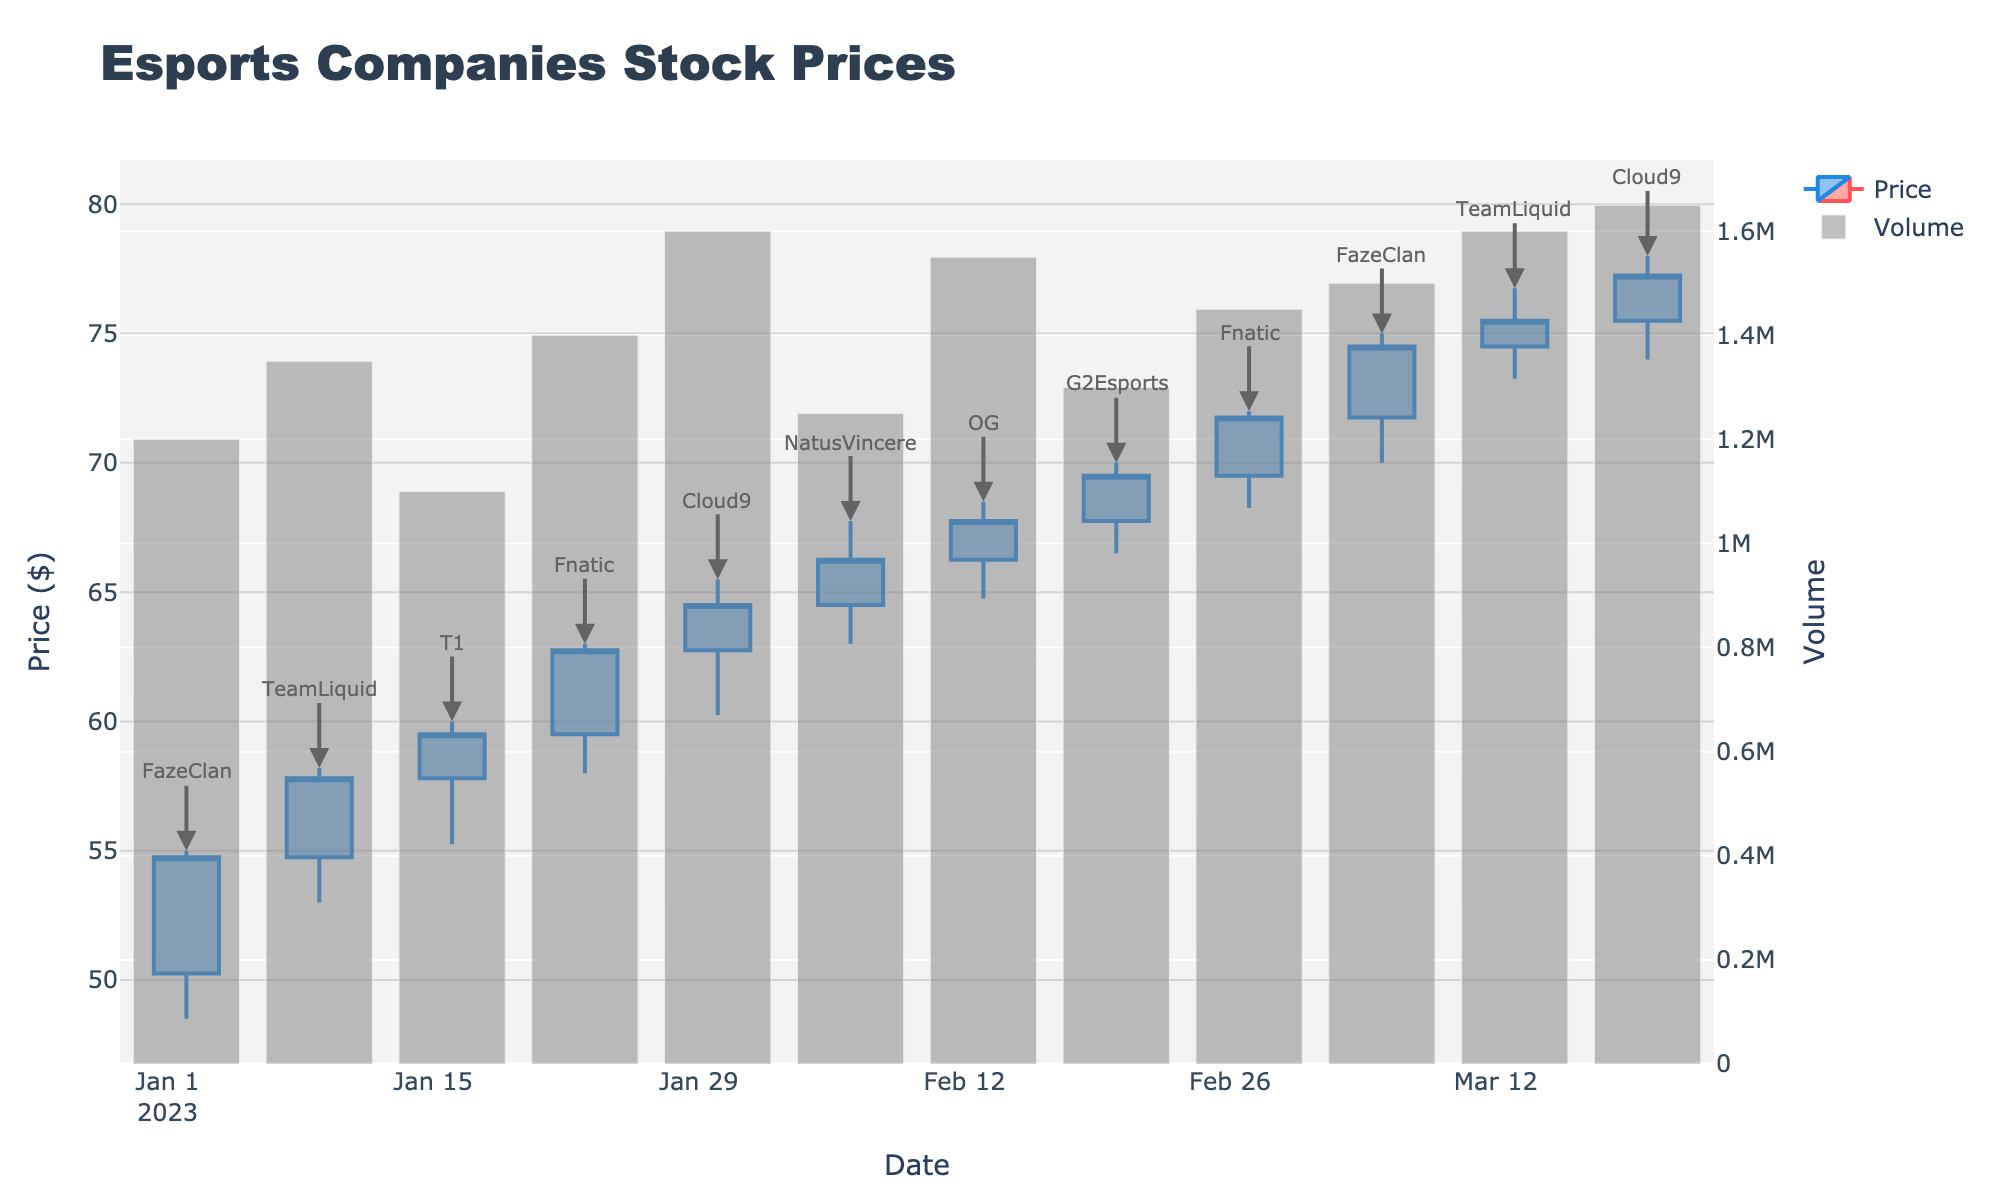What is the highest stock price recorded in the figure? Look for the candlestick with the highest "High" value on the vertical axis. The highest price recorded is 78.00 on 2023-03-20 for Cloud9.
Answer: 78.00 Which company had the highest trading volume? Refer to the volume bars at the bottom of the chart and identify the tallest bar, which corresponds to the highest trading volume. The company with the highest volume is Cloud9 on 2023-03-20, with a volume of 1,650,000.
Answer: Cloud9 How does the closing price of TeamLiquid on 2023-01-09 compare to its opening price? Check TeamLiquid’s candlestick on 2023-01-09. The candlestick is blue indicating an increase. The opening price was 54.75, and the closing price was 57.80. Calculate the difference: 57.80 - 54.75 = 3.05.
Answer: 3.05 What is the average closing price across all companies in February? List all February closing prices: 66.25, 67.75, 69.50, and 71.75. Sum these values (66.25 + 67.75 + 69.50 + 71.75 = 275.25) and divide by the number of values (275.25/4).
Answer: 68.81 Which company shows the greatest overall increase in stock price from open to close within the given dates? Compare the difference between the opening and closing prices for all companies. Start with FazeClan (2023-01-02: 4.50), TeamLiquid (2023-01-09: 3.05), T1 (2023-01-16: 1.70), Fnatic (2023-01-23: 3.25), Cloud9 (2023-02-20: 1.75), and so on. The greatest increase is seen on 2023-01-02 for FazeClan, which is 4.50.
Answer: FazeClan On which date did Fnatic experience a major increase in its stock price? Look at the candlestick annotations and identify the dates marked for Fnatic. Highlight the candlesticks and review the opening/closing prices to confirm the increase. The major increase happened on 2023-01-23, from 59.50 to 62.75.
Answer: 2023-01-23 How does the volume of Cloud9 on 2023-01-30 compare to its volume on 2023-03-20? Identify and compare the volumes of Cloud9 on these dates. 2023-01-30 has a volume of 1,600,000 and 2023-03-20 has a volume of 1,650,000. The difference is 1,650,000 - 1,600,000 = 50,000.
Answer: 50,000 Did any company experience a decrease in stock price during the given timeframe? If so, which one and when? Check for red candlesticks throughout the figure, where the closing price is lower than the opening price. None of the candlesticks indicate a decrease in stock price for any company during this period.
Answer: No 